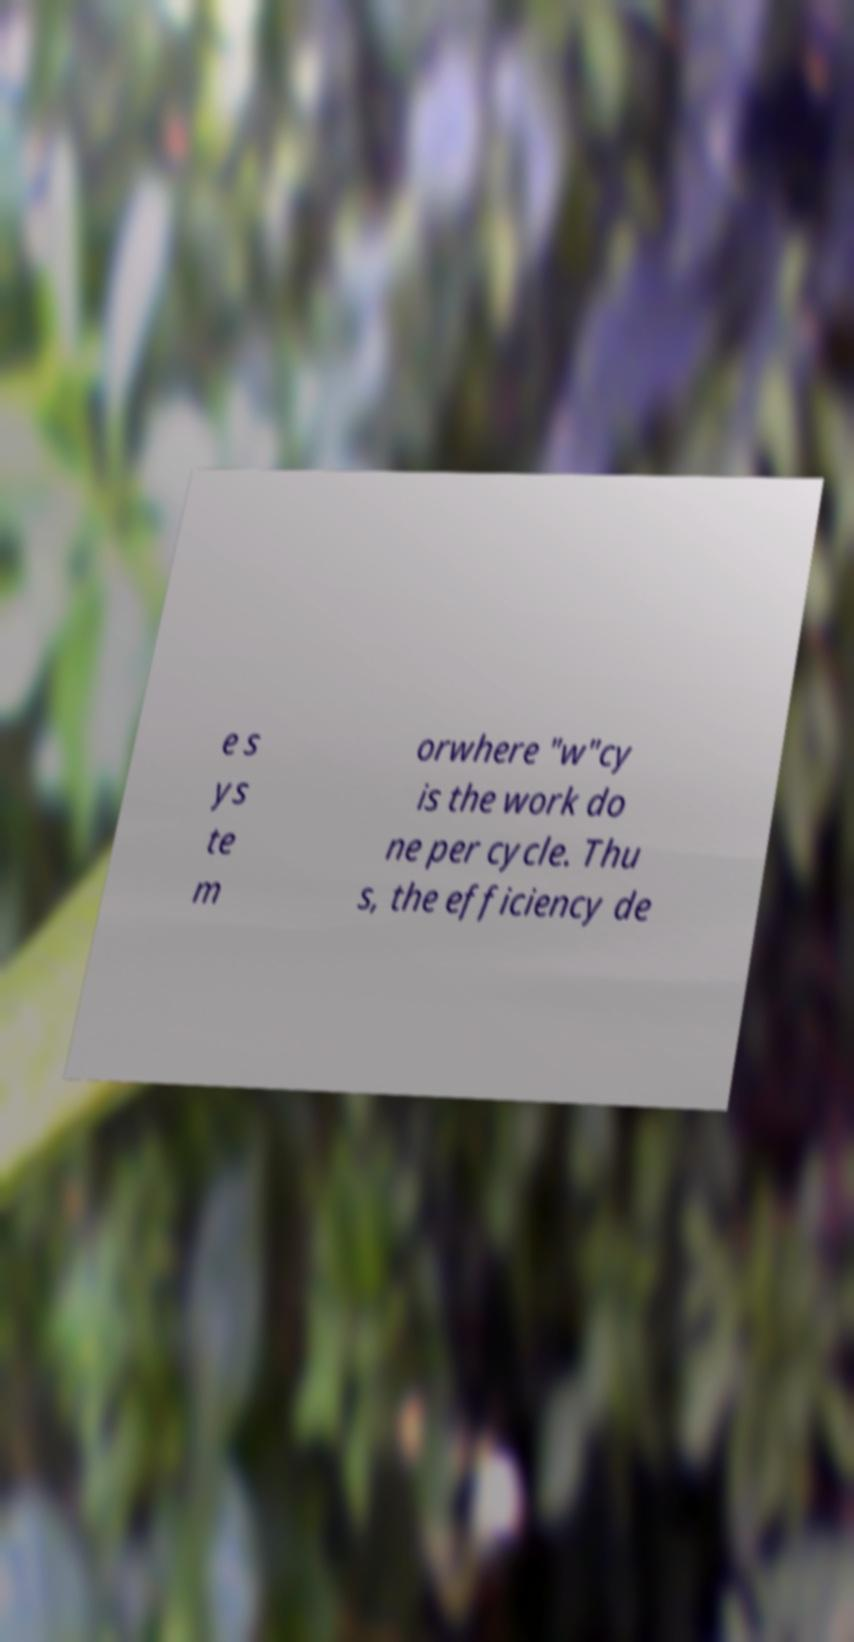There's text embedded in this image that I need extracted. Can you transcribe it verbatim? e s ys te m orwhere "w"cy is the work do ne per cycle. Thu s, the efficiency de 